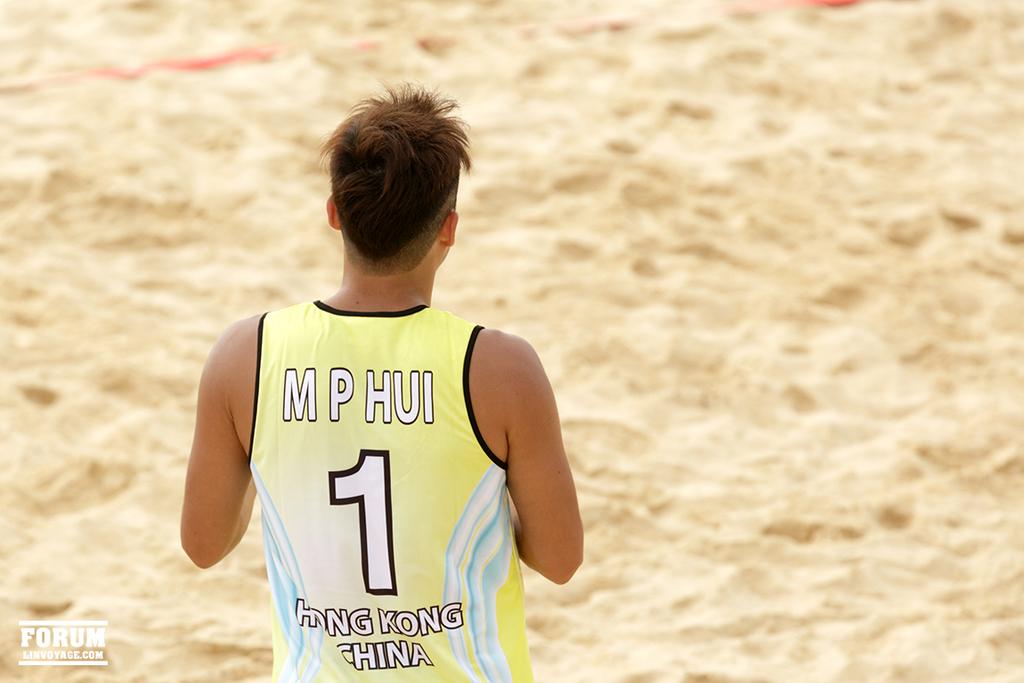What number is m p hui?
Your answer should be very brief. 1. What country is on the player's shirt?
Offer a terse response. China. 